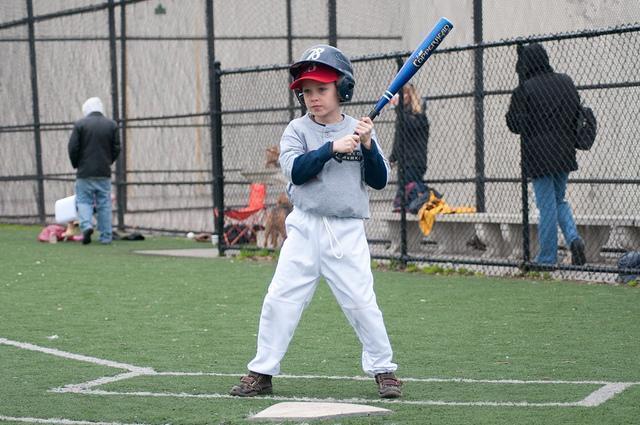How many people are visible?
Give a very brief answer. 4. 